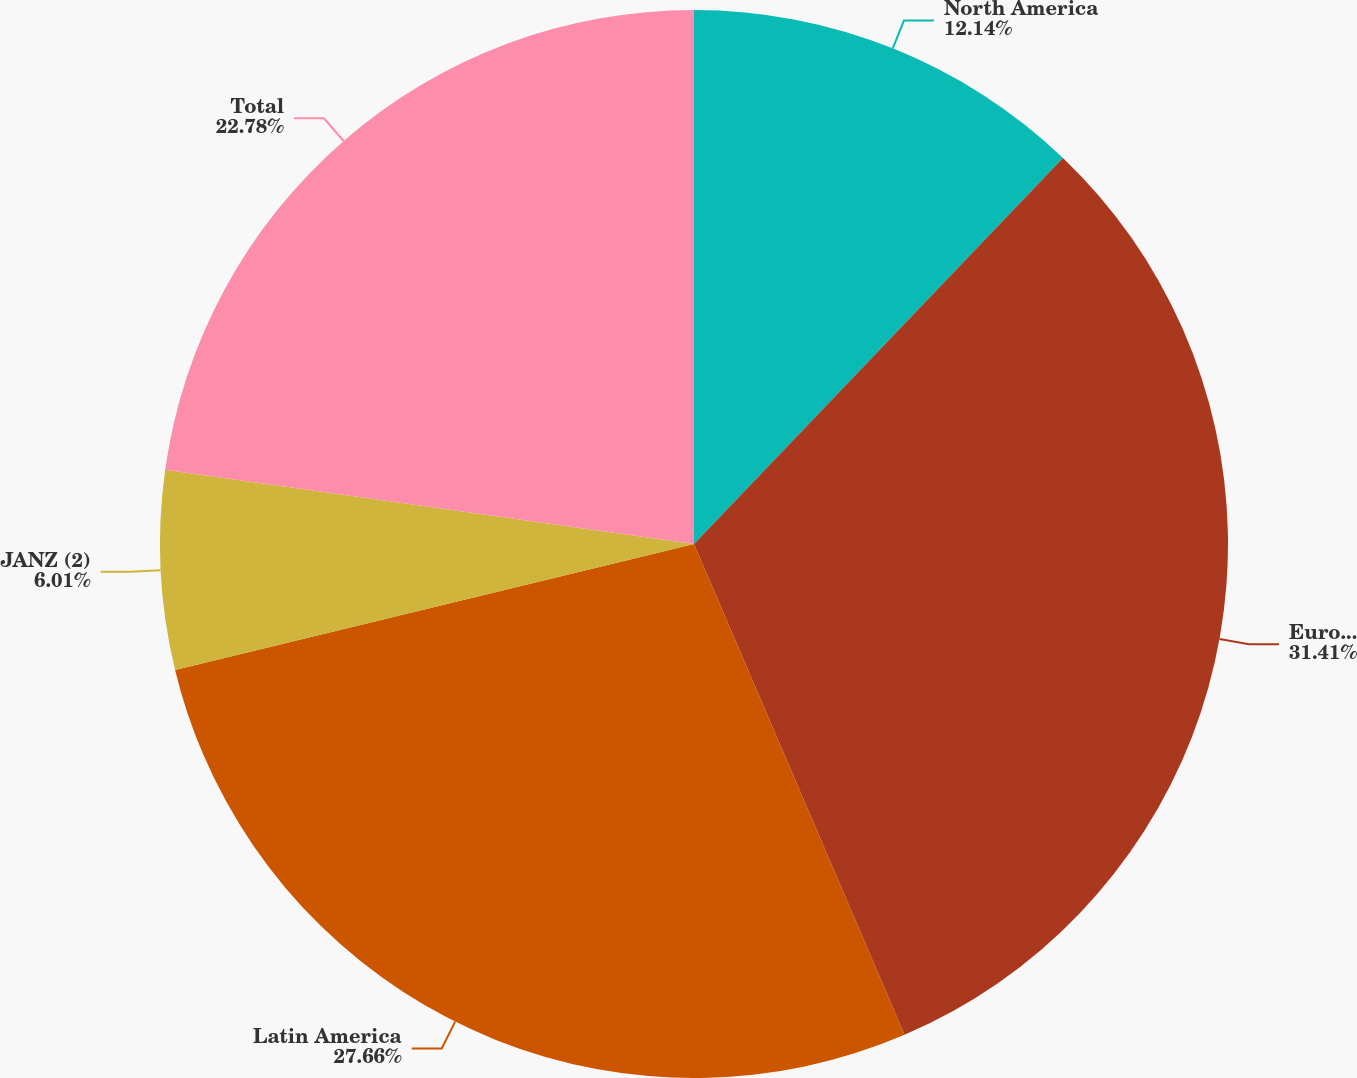Convert chart. <chart><loc_0><loc_0><loc_500><loc_500><pie_chart><fcel>North America<fcel>Europe<fcel>Latin America<fcel>JANZ (2)<fcel>Total<nl><fcel>12.14%<fcel>31.41%<fcel>27.66%<fcel>6.01%<fcel>22.78%<nl></chart> 